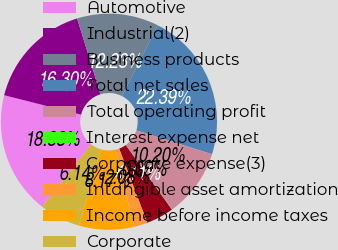Convert chart to OTSL. <chart><loc_0><loc_0><loc_500><loc_500><pie_chart><fcel>Automotive<fcel>Industrial(2)<fcel>Business products<fcel>Total net sales<fcel>Total operating profit<fcel>Interest expense net<fcel>Corporate expense(3)<fcel>Intangible asset amortization<fcel>Income before income taxes<fcel>Corporate<nl><fcel>18.33%<fcel>16.3%<fcel>12.23%<fcel>22.39%<fcel>10.2%<fcel>0.05%<fcel>4.11%<fcel>2.08%<fcel>8.17%<fcel>6.14%<nl></chart> 